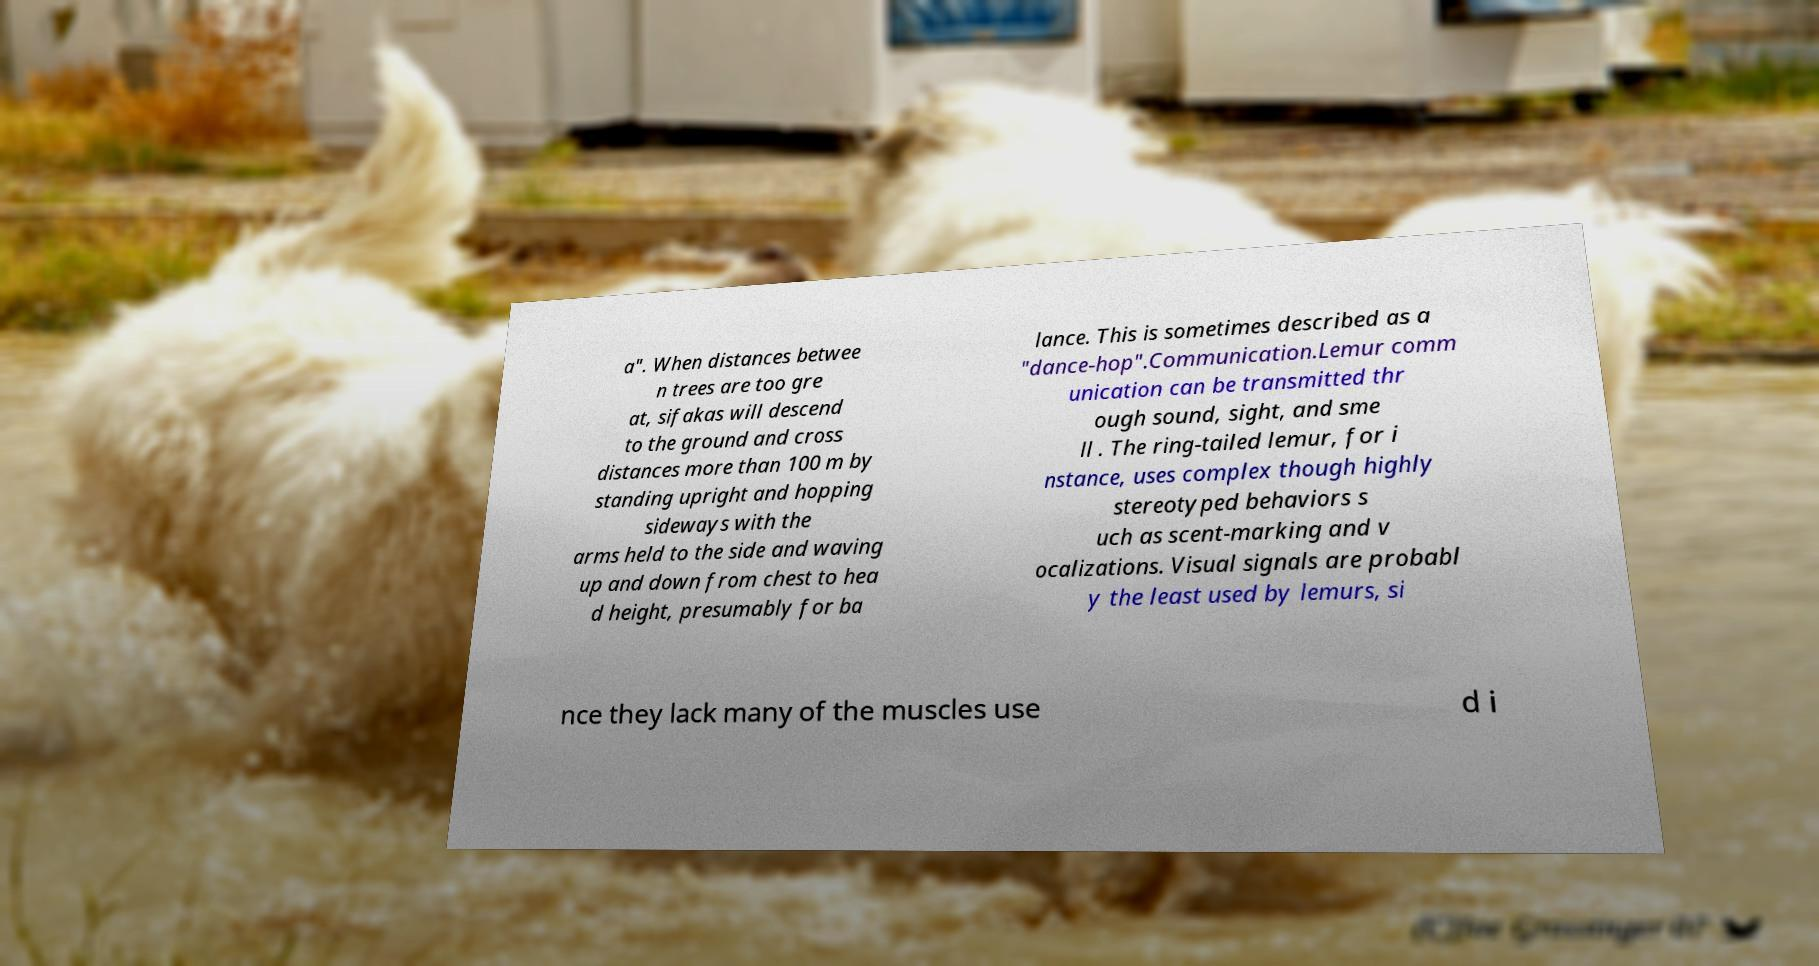Could you extract and type out the text from this image? a". When distances betwee n trees are too gre at, sifakas will descend to the ground and cross distances more than 100 m by standing upright and hopping sideways with the arms held to the side and waving up and down from chest to hea d height, presumably for ba lance. This is sometimes described as a "dance-hop".Communication.Lemur comm unication can be transmitted thr ough sound, sight, and sme ll . The ring-tailed lemur, for i nstance, uses complex though highly stereotyped behaviors s uch as scent-marking and v ocalizations. Visual signals are probabl y the least used by lemurs, si nce they lack many of the muscles use d i 